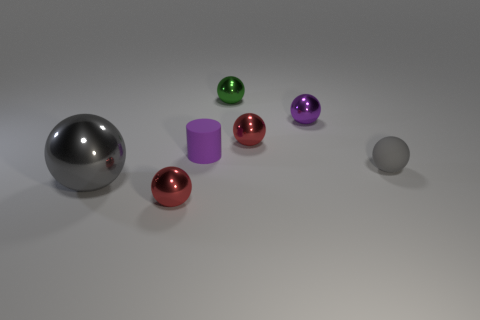Does the arrangement of the objects suggest anything particular about their relationship or purpose? The objects are spaced evenly and appear to be organized by size, creating a visually pleasing gradient effect from left to right. This arrangement could suggest an aesthetic intention, positioning the objects to be visually appealing rather than functional. 